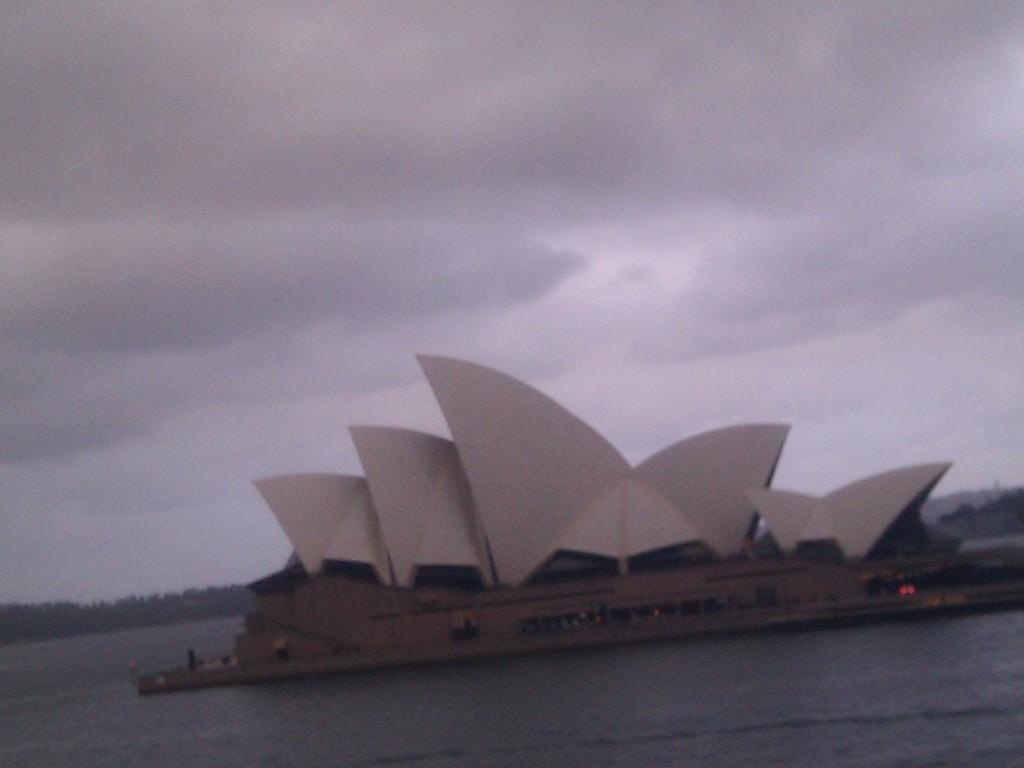What famous landmark can be seen in the image? The Sydney Opera House is visible in the image. What natural feature is present at the bottom of the image? There is sea at the bottom of the image. What type of vegetation is in the background of the image? There are trees in the background of the image. How would you describe the sky in the image? The sky is cloudy in the background of the image. What type of haircut does the aunt have in the image? There is no aunt present in the image, so it is not possible to answer that question. 